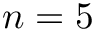Convert formula to latex. <formula><loc_0><loc_0><loc_500><loc_500>n = 5</formula> 